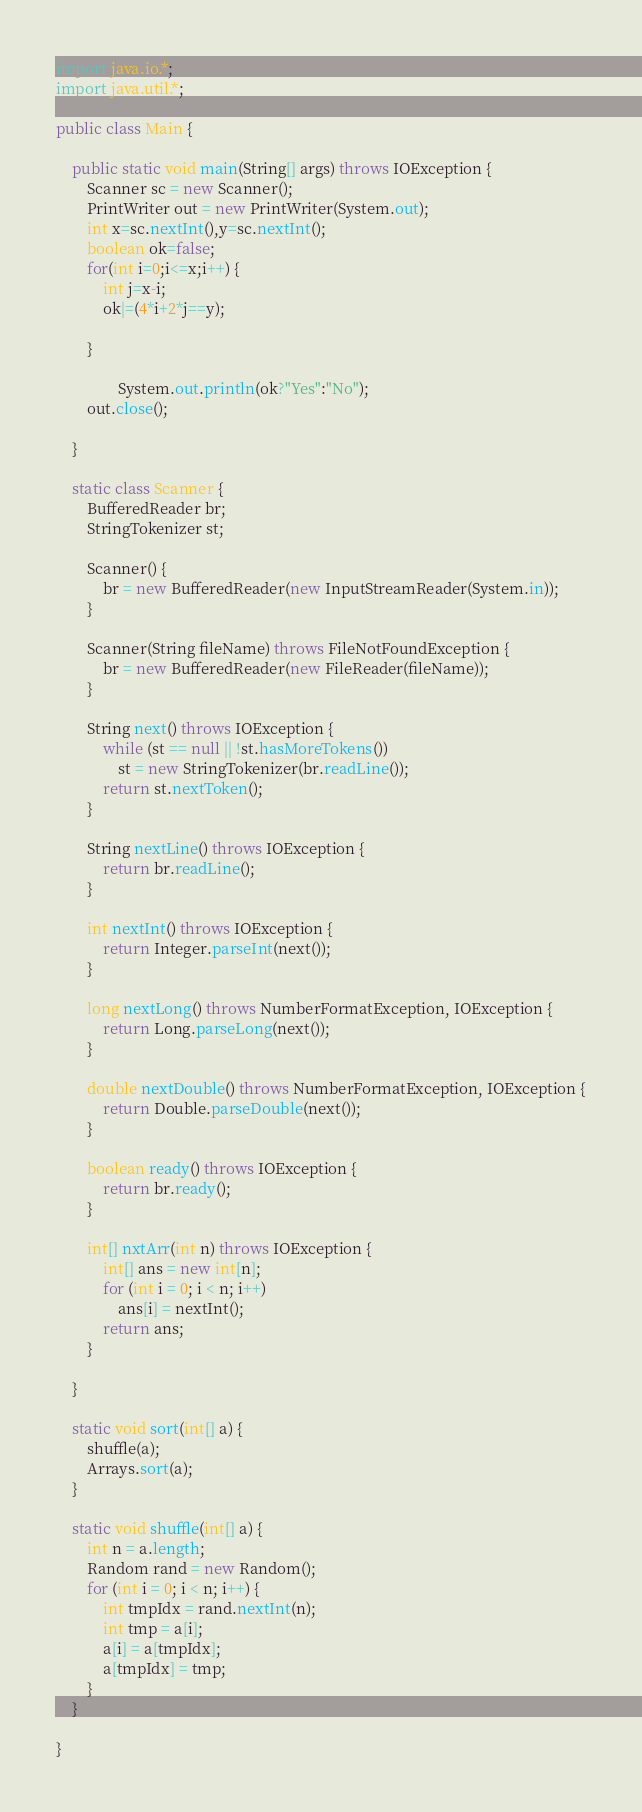Convert code to text. <code><loc_0><loc_0><loc_500><loc_500><_Java_>import java.io.*;
import java.util.*;

public class Main {

	public static void main(String[] args) throws IOException {
		Scanner sc = new Scanner();
		PrintWriter out = new PrintWriter(System.out);
		int x=sc.nextInt(),y=sc.nextInt();
		boolean ok=false;
		for(int i=0;i<=x;i++) {
			int j=x-i;
			ok|=(4*i+2*j==y);
			
		}
		
				System.out.println(ok?"Yes":"No");
		out.close();

	}

	static class Scanner {
		BufferedReader br;
		StringTokenizer st;

		Scanner() {
			br = new BufferedReader(new InputStreamReader(System.in));
		}

		Scanner(String fileName) throws FileNotFoundException {
			br = new BufferedReader(new FileReader(fileName));
		}

		String next() throws IOException {
			while (st == null || !st.hasMoreTokens())
				st = new StringTokenizer(br.readLine());
			return st.nextToken();
		}

		String nextLine() throws IOException {
			return br.readLine();
		}

		int nextInt() throws IOException {
			return Integer.parseInt(next());
		}

		long nextLong() throws NumberFormatException, IOException {
			return Long.parseLong(next());
		}

		double nextDouble() throws NumberFormatException, IOException {
			return Double.parseDouble(next());
		}

		boolean ready() throws IOException {
			return br.ready();
		}

		int[] nxtArr(int n) throws IOException {
			int[] ans = new int[n];
			for (int i = 0; i < n; i++)
				ans[i] = nextInt();
			return ans;
		}

	}

	static void sort(int[] a) {
		shuffle(a);
		Arrays.sort(a);
	}

	static void shuffle(int[] a) {
		int n = a.length;
		Random rand = new Random();
		for (int i = 0; i < n; i++) {
			int tmpIdx = rand.nextInt(n);
			int tmp = a[i];
			a[i] = a[tmpIdx];
			a[tmpIdx] = tmp;
		}
	}

}</code> 